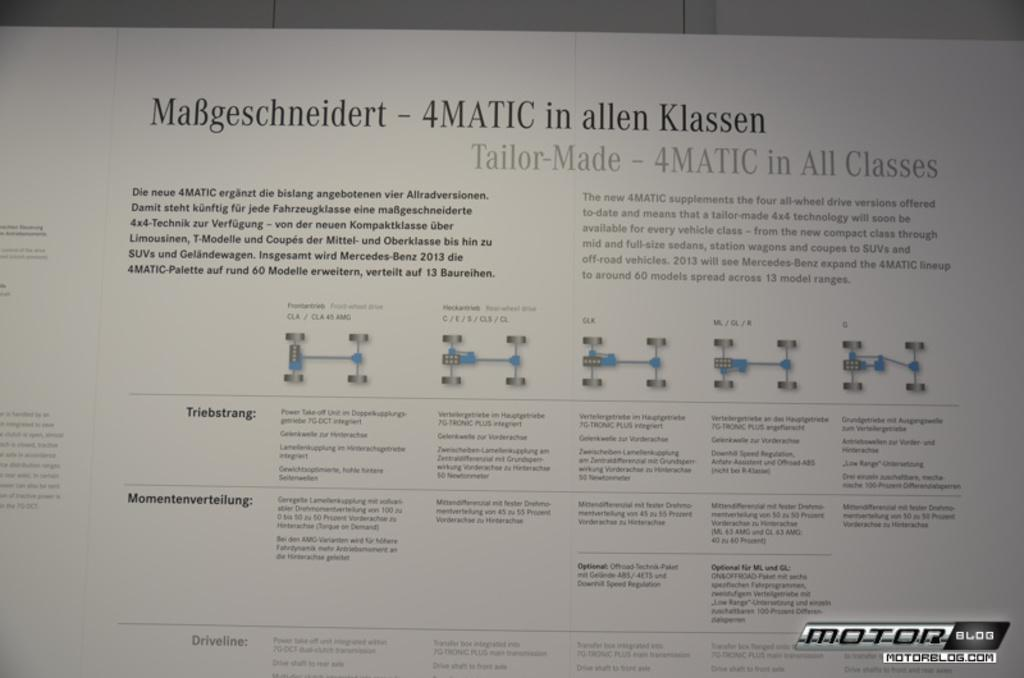<image>
Provide a brief description of the given image. A piece of paper with instructions on it and the words 4MATIC. 